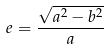<formula> <loc_0><loc_0><loc_500><loc_500>e = \frac { \sqrt { a ^ { 2 } - b ^ { 2 } } } { a }</formula> 